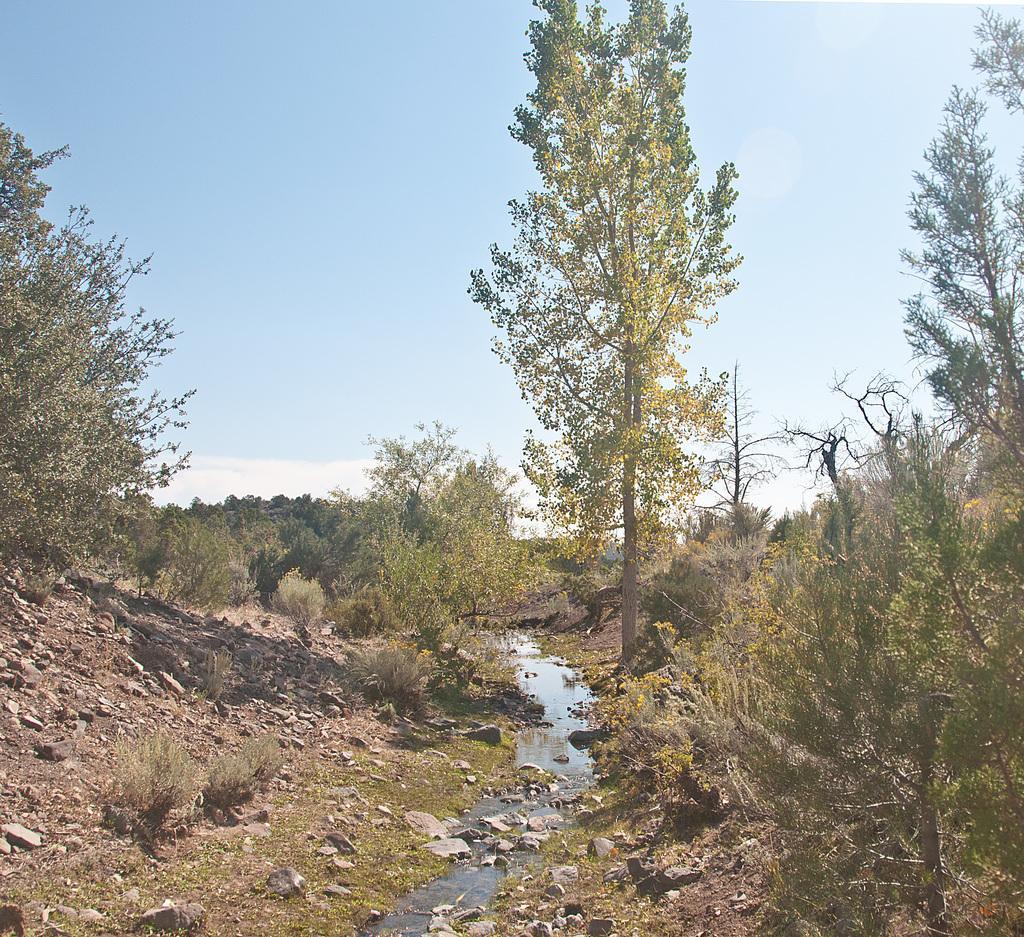Could you give a brief overview of what you see in this image? In this picture, we can see the ground with stones, grass, plants, trees, we can see water, and the sky with clouds. 